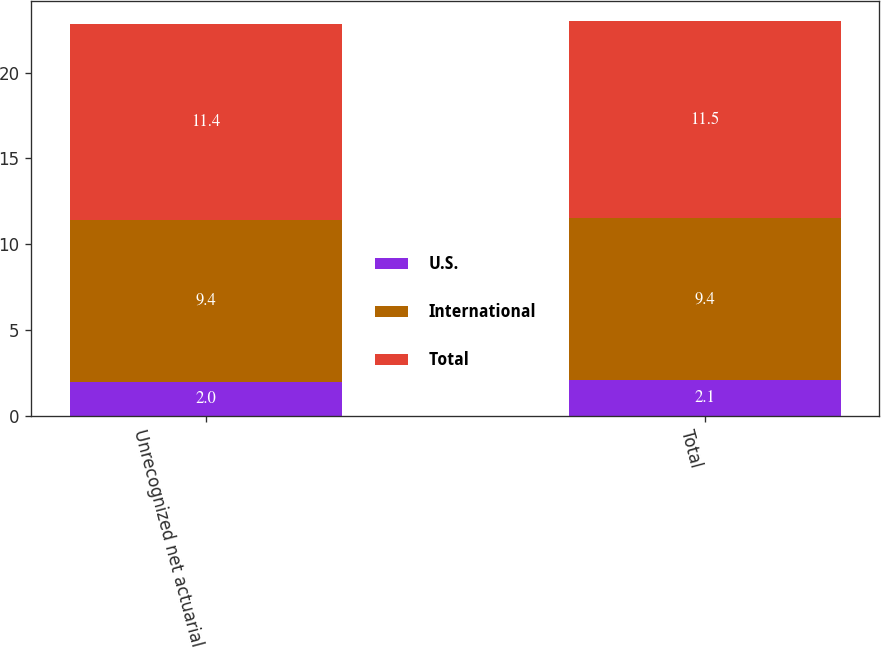Convert chart. <chart><loc_0><loc_0><loc_500><loc_500><stacked_bar_chart><ecel><fcel>Unrecognized net actuarial<fcel>Total<nl><fcel>U.S.<fcel>2<fcel>2.1<nl><fcel>International<fcel>9.4<fcel>9.4<nl><fcel>Total<fcel>11.4<fcel>11.5<nl></chart> 